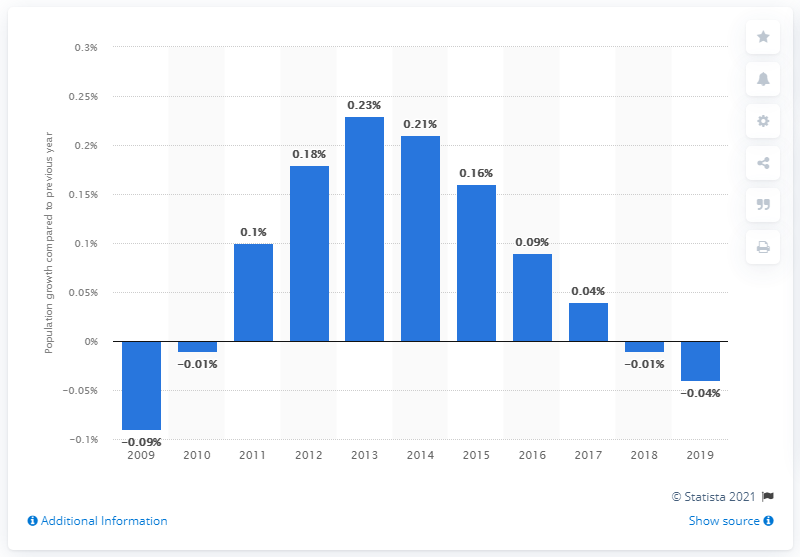List a handful of essential elements in this visual. In 2019, the population of Cuba decreased by approximately 0.04%. 